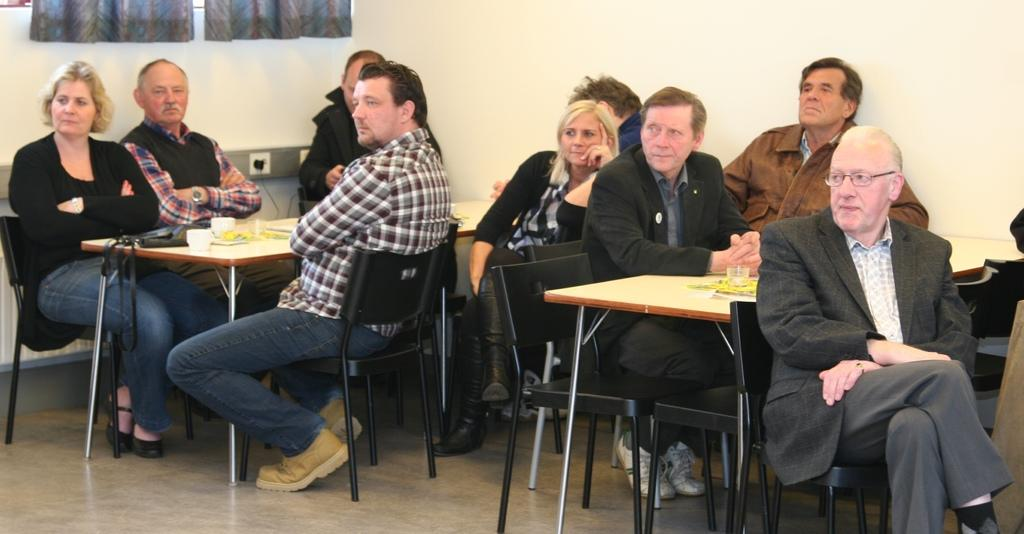What can be seen in the background of the image? There is a wall and curtains in the background of the image. What are the people in the image doing? The persons are sitting on chairs in front of a table. What is on the table in the image? There is a glass and cups on the table. What is the surface on which the table and chairs are placed? The scene takes place on a floor. What type of knee surgery is being performed in the image? There is no knee surgery or any medical procedure depicted in the image. What invention is being showcased on the table in the image? There is no invention present on the table in the image; only a glass and cups are visible. 